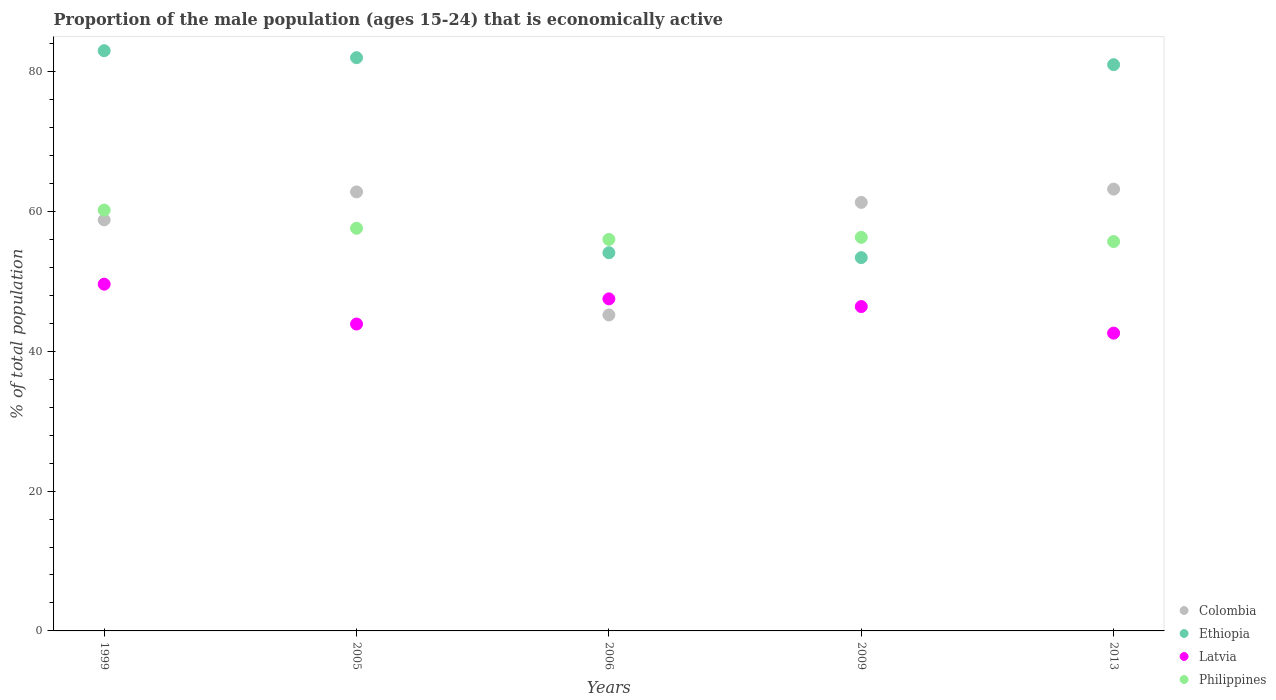Is the number of dotlines equal to the number of legend labels?
Ensure brevity in your answer.  Yes. What is the proportion of the male population that is economically active in Latvia in 2009?
Ensure brevity in your answer.  46.4. Across all years, what is the maximum proportion of the male population that is economically active in Colombia?
Your answer should be compact. 63.2. Across all years, what is the minimum proportion of the male population that is economically active in Philippines?
Your answer should be very brief. 55.7. In which year was the proportion of the male population that is economically active in Philippines minimum?
Make the answer very short. 2013. What is the total proportion of the male population that is economically active in Colombia in the graph?
Offer a very short reply. 291.3. What is the difference between the proportion of the male population that is economically active in Ethiopia in 2009 and that in 2013?
Your answer should be compact. -27.6. What is the difference between the proportion of the male population that is economically active in Philippines in 2005 and the proportion of the male population that is economically active in Ethiopia in 2009?
Give a very brief answer. 4.2. What is the average proportion of the male population that is economically active in Colombia per year?
Make the answer very short. 58.26. In the year 2006, what is the difference between the proportion of the male population that is economically active in Philippines and proportion of the male population that is economically active in Latvia?
Give a very brief answer. 8.5. In how many years, is the proportion of the male population that is economically active in Philippines greater than 36 %?
Keep it short and to the point. 5. What is the ratio of the proportion of the male population that is economically active in Ethiopia in 1999 to that in 2009?
Provide a succinct answer. 1.55. Is the difference between the proportion of the male population that is economically active in Philippines in 1999 and 2009 greater than the difference between the proportion of the male population that is economically active in Latvia in 1999 and 2009?
Your answer should be very brief. Yes. What is the difference between the highest and the second highest proportion of the male population that is economically active in Colombia?
Provide a succinct answer. 0.4. What is the difference between the highest and the lowest proportion of the male population that is economically active in Latvia?
Provide a succinct answer. 7. Is it the case that in every year, the sum of the proportion of the male population that is economically active in Latvia and proportion of the male population that is economically active in Ethiopia  is greater than the sum of proportion of the male population that is economically active in Philippines and proportion of the male population that is economically active in Colombia?
Keep it short and to the point. Yes. Does the proportion of the male population that is economically active in Latvia monotonically increase over the years?
Make the answer very short. No. Is the proportion of the male population that is economically active in Ethiopia strictly less than the proportion of the male population that is economically active in Colombia over the years?
Provide a short and direct response. No. What is the difference between two consecutive major ticks on the Y-axis?
Give a very brief answer. 20. Are the values on the major ticks of Y-axis written in scientific E-notation?
Your answer should be very brief. No. Does the graph contain any zero values?
Keep it short and to the point. No. Does the graph contain grids?
Give a very brief answer. No. Where does the legend appear in the graph?
Make the answer very short. Bottom right. How many legend labels are there?
Ensure brevity in your answer.  4. What is the title of the graph?
Provide a short and direct response. Proportion of the male population (ages 15-24) that is economically active. Does "Northern Mariana Islands" appear as one of the legend labels in the graph?
Offer a terse response. No. What is the label or title of the Y-axis?
Provide a succinct answer. % of total population. What is the % of total population of Colombia in 1999?
Offer a very short reply. 58.8. What is the % of total population in Latvia in 1999?
Ensure brevity in your answer.  49.6. What is the % of total population in Philippines in 1999?
Make the answer very short. 60.2. What is the % of total population in Colombia in 2005?
Give a very brief answer. 62.8. What is the % of total population of Ethiopia in 2005?
Ensure brevity in your answer.  82. What is the % of total population in Latvia in 2005?
Give a very brief answer. 43.9. What is the % of total population in Philippines in 2005?
Ensure brevity in your answer.  57.6. What is the % of total population in Colombia in 2006?
Your answer should be compact. 45.2. What is the % of total population of Ethiopia in 2006?
Keep it short and to the point. 54.1. What is the % of total population of Latvia in 2006?
Make the answer very short. 47.5. What is the % of total population of Philippines in 2006?
Offer a terse response. 56. What is the % of total population in Colombia in 2009?
Keep it short and to the point. 61.3. What is the % of total population in Ethiopia in 2009?
Keep it short and to the point. 53.4. What is the % of total population of Latvia in 2009?
Offer a terse response. 46.4. What is the % of total population in Philippines in 2009?
Offer a terse response. 56.3. What is the % of total population of Colombia in 2013?
Your response must be concise. 63.2. What is the % of total population of Latvia in 2013?
Provide a short and direct response. 42.6. What is the % of total population of Philippines in 2013?
Offer a very short reply. 55.7. Across all years, what is the maximum % of total population of Colombia?
Give a very brief answer. 63.2. Across all years, what is the maximum % of total population in Ethiopia?
Offer a very short reply. 83. Across all years, what is the maximum % of total population of Latvia?
Keep it short and to the point. 49.6. Across all years, what is the maximum % of total population of Philippines?
Offer a very short reply. 60.2. Across all years, what is the minimum % of total population in Colombia?
Give a very brief answer. 45.2. Across all years, what is the minimum % of total population of Ethiopia?
Offer a very short reply. 53.4. Across all years, what is the minimum % of total population of Latvia?
Your answer should be compact. 42.6. Across all years, what is the minimum % of total population in Philippines?
Offer a very short reply. 55.7. What is the total % of total population in Colombia in the graph?
Your answer should be compact. 291.3. What is the total % of total population in Ethiopia in the graph?
Your response must be concise. 353.5. What is the total % of total population in Latvia in the graph?
Provide a succinct answer. 230. What is the total % of total population of Philippines in the graph?
Your response must be concise. 285.8. What is the difference between the % of total population of Philippines in 1999 and that in 2005?
Offer a very short reply. 2.6. What is the difference between the % of total population of Ethiopia in 1999 and that in 2006?
Offer a terse response. 28.9. What is the difference between the % of total population of Latvia in 1999 and that in 2006?
Your answer should be very brief. 2.1. What is the difference between the % of total population of Philippines in 1999 and that in 2006?
Offer a terse response. 4.2. What is the difference between the % of total population of Colombia in 1999 and that in 2009?
Offer a terse response. -2.5. What is the difference between the % of total population of Ethiopia in 1999 and that in 2009?
Offer a terse response. 29.6. What is the difference between the % of total population of Latvia in 1999 and that in 2009?
Provide a succinct answer. 3.2. What is the difference between the % of total population in Colombia in 1999 and that in 2013?
Make the answer very short. -4.4. What is the difference between the % of total population in Colombia in 2005 and that in 2006?
Give a very brief answer. 17.6. What is the difference between the % of total population of Ethiopia in 2005 and that in 2006?
Your response must be concise. 27.9. What is the difference between the % of total population in Latvia in 2005 and that in 2006?
Your answer should be very brief. -3.6. What is the difference between the % of total population of Colombia in 2005 and that in 2009?
Your answer should be compact. 1.5. What is the difference between the % of total population of Ethiopia in 2005 and that in 2009?
Provide a succinct answer. 28.6. What is the difference between the % of total population in Latvia in 2005 and that in 2009?
Give a very brief answer. -2.5. What is the difference between the % of total population of Philippines in 2005 and that in 2009?
Your answer should be very brief. 1.3. What is the difference between the % of total population of Colombia in 2005 and that in 2013?
Offer a terse response. -0.4. What is the difference between the % of total population in Ethiopia in 2005 and that in 2013?
Give a very brief answer. 1. What is the difference between the % of total population of Philippines in 2005 and that in 2013?
Offer a terse response. 1.9. What is the difference between the % of total population of Colombia in 2006 and that in 2009?
Make the answer very short. -16.1. What is the difference between the % of total population of Ethiopia in 2006 and that in 2009?
Your response must be concise. 0.7. What is the difference between the % of total population in Colombia in 2006 and that in 2013?
Keep it short and to the point. -18. What is the difference between the % of total population of Ethiopia in 2006 and that in 2013?
Offer a very short reply. -26.9. What is the difference between the % of total population in Philippines in 2006 and that in 2013?
Ensure brevity in your answer.  0.3. What is the difference between the % of total population of Colombia in 2009 and that in 2013?
Offer a terse response. -1.9. What is the difference between the % of total population in Ethiopia in 2009 and that in 2013?
Give a very brief answer. -27.6. What is the difference between the % of total population of Philippines in 2009 and that in 2013?
Your response must be concise. 0.6. What is the difference between the % of total population in Colombia in 1999 and the % of total population in Ethiopia in 2005?
Ensure brevity in your answer.  -23.2. What is the difference between the % of total population of Colombia in 1999 and the % of total population of Philippines in 2005?
Keep it short and to the point. 1.2. What is the difference between the % of total population in Ethiopia in 1999 and the % of total population in Latvia in 2005?
Provide a succinct answer. 39.1. What is the difference between the % of total population of Ethiopia in 1999 and the % of total population of Philippines in 2005?
Make the answer very short. 25.4. What is the difference between the % of total population in Ethiopia in 1999 and the % of total population in Latvia in 2006?
Your answer should be very brief. 35.5. What is the difference between the % of total population of Colombia in 1999 and the % of total population of Latvia in 2009?
Give a very brief answer. 12.4. What is the difference between the % of total population of Ethiopia in 1999 and the % of total population of Latvia in 2009?
Make the answer very short. 36.6. What is the difference between the % of total population of Ethiopia in 1999 and the % of total population of Philippines in 2009?
Offer a terse response. 26.7. What is the difference between the % of total population in Latvia in 1999 and the % of total population in Philippines in 2009?
Provide a short and direct response. -6.7. What is the difference between the % of total population in Colombia in 1999 and the % of total population in Ethiopia in 2013?
Your answer should be very brief. -22.2. What is the difference between the % of total population in Colombia in 1999 and the % of total population in Philippines in 2013?
Your answer should be compact. 3.1. What is the difference between the % of total population of Ethiopia in 1999 and the % of total population of Latvia in 2013?
Ensure brevity in your answer.  40.4. What is the difference between the % of total population in Ethiopia in 1999 and the % of total population in Philippines in 2013?
Offer a terse response. 27.3. What is the difference between the % of total population of Colombia in 2005 and the % of total population of Ethiopia in 2006?
Give a very brief answer. 8.7. What is the difference between the % of total population in Colombia in 2005 and the % of total population in Latvia in 2006?
Provide a succinct answer. 15.3. What is the difference between the % of total population in Colombia in 2005 and the % of total population in Philippines in 2006?
Provide a succinct answer. 6.8. What is the difference between the % of total population of Ethiopia in 2005 and the % of total population of Latvia in 2006?
Your response must be concise. 34.5. What is the difference between the % of total population in Latvia in 2005 and the % of total population in Philippines in 2006?
Your response must be concise. -12.1. What is the difference between the % of total population of Colombia in 2005 and the % of total population of Latvia in 2009?
Ensure brevity in your answer.  16.4. What is the difference between the % of total population of Ethiopia in 2005 and the % of total population of Latvia in 2009?
Provide a short and direct response. 35.6. What is the difference between the % of total population in Ethiopia in 2005 and the % of total population in Philippines in 2009?
Make the answer very short. 25.7. What is the difference between the % of total population in Latvia in 2005 and the % of total population in Philippines in 2009?
Make the answer very short. -12.4. What is the difference between the % of total population in Colombia in 2005 and the % of total population in Ethiopia in 2013?
Offer a terse response. -18.2. What is the difference between the % of total population in Colombia in 2005 and the % of total population in Latvia in 2013?
Ensure brevity in your answer.  20.2. What is the difference between the % of total population of Colombia in 2005 and the % of total population of Philippines in 2013?
Offer a terse response. 7.1. What is the difference between the % of total population of Ethiopia in 2005 and the % of total population of Latvia in 2013?
Your response must be concise. 39.4. What is the difference between the % of total population in Ethiopia in 2005 and the % of total population in Philippines in 2013?
Ensure brevity in your answer.  26.3. What is the difference between the % of total population in Colombia in 2006 and the % of total population in Ethiopia in 2009?
Provide a short and direct response. -8.2. What is the difference between the % of total population of Colombia in 2006 and the % of total population of Ethiopia in 2013?
Your answer should be compact. -35.8. What is the difference between the % of total population of Ethiopia in 2006 and the % of total population of Latvia in 2013?
Give a very brief answer. 11.5. What is the difference between the % of total population of Colombia in 2009 and the % of total population of Ethiopia in 2013?
Your response must be concise. -19.7. What is the difference between the % of total population in Ethiopia in 2009 and the % of total population in Latvia in 2013?
Provide a short and direct response. 10.8. What is the difference between the % of total population of Latvia in 2009 and the % of total population of Philippines in 2013?
Offer a very short reply. -9.3. What is the average % of total population in Colombia per year?
Your answer should be compact. 58.26. What is the average % of total population of Ethiopia per year?
Provide a short and direct response. 70.7. What is the average % of total population of Philippines per year?
Ensure brevity in your answer.  57.16. In the year 1999, what is the difference between the % of total population of Colombia and % of total population of Ethiopia?
Provide a succinct answer. -24.2. In the year 1999, what is the difference between the % of total population in Colombia and % of total population in Philippines?
Offer a very short reply. -1.4. In the year 1999, what is the difference between the % of total population of Ethiopia and % of total population of Latvia?
Provide a succinct answer. 33.4. In the year 1999, what is the difference between the % of total population of Ethiopia and % of total population of Philippines?
Ensure brevity in your answer.  22.8. In the year 2005, what is the difference between the % of total population in Colombia and % of total population in Ethiopia?
Your response must be concise. -19.2. In the year 2005, what is the difference between the % of total population in Ethiopia and % of total population in Latvia?
Ensure brevity in your answer.  38.1. In the year 2005, what is the difference between the % of total population of Ethiopia and % of total population of Philippines?
Your response must be concise. 24.4. In the year 2005, what is the difference between the % of total population of Latvia and % of total population of Philippines?
Your answer should be compact. -13.7. In the year 2006, what is the difference between the % of total population in Colombia and % of total population in Ethiopia?
Your answer should be compact. -8.9. In the year 2006, what is the difference between the % of total population of Colombia and % of total population of Latvia?
Make the answer very short. -2.3. In the year 2006, what is the difference between the % of total population in Ethiopia and % of total population in Philippines?
Give a very brief answer. -1.9. In the year 2006, what is the difference between the % of total population of Latvia and % of total population of Philippines?
Provide a succinct answer. -8.5. In the year 2009, what is the difference between the % of total population in Colombia and % of total population in Ethiopia?
Make the answer very short. 7.9. In the year 2009, what is the difference between the % of total population in Colombia and % of total population in Latvia?
Your answer should be very brief. 14.9. In the year 2009, what is the difference between the % of total population of Ethiopia and % of total population of Latvia?
Offer a very short reply. 7. In the year 2009, what is the difference between the % of total population in Ethiopia and % of total population in Philippines?
Keep it short and to the point. -2.9. In the year 2009, what is the difference between the % of total population of Latvia and % of total population of Philippines?
Make the answer very short. -9.9. In the year 2013, what is the difference between the % of total population in Colombia and % of total population in Ethiopia?
Your answer should be very brief. -17.8. In the year 2013, what is the difference between the % of total population in Colombia and % of total population in Latvia?
Offer a very short reply. 20.6. In the year 2013, what is the difference between the % of total population in Ethiopia and % of total population in Latvia?
Your answer should be very brief. 38.4. In the year 2013, what is the difference between the % of total population in Ethiopia and % of total population in Philippines?
Ensure brevity in your answer.  25.3. What is the ratio of the % of total population in Colombia in 1999 to that in 2005?
Keep it short and to the point. 0.94. What is the ratio of the % of total population in Ethiopia in 1999 to that in 2005?
Provide a short and direct response. 1.01. What is the ratio of the % of total population of Latvia in 1999 to that in 2005?
Your answer should be very brief. 1.13. What is the ratio of the % of total population of Philippines in 1999 to that in 2005?
Your answer should be compact. 1.05. What is the ratio of the % of total population of Colombia in 1999 to that in 2006?
Your answer should be very brief. 1.3. What is the ratio of the % of total population of Ethiopia in 1999 to that in 2006?
Your answer should be very brief. 1.53. What is the ratio of the % of total population in Latvia in 1999 to that in 2006?
Your answer should be compact. 1.04. What is the ratio of the % of total population of Philippines in 1999 to that in 2006?
Your response must be concise. 1.07. What is the ratio of the % of total population of Colombia in 1999 to that in 2009?
Keep it short and to the point. 0.96. What is the ratio of the % of total population in Ethiopia in 1999 to that in 2009?
Ensure brevity in your answer.  1.55. What is the ratio of the % of total population in Latvia in 1999 to that in 2009?
Your response must be concise. 1.07. What is the ratio of the % of total population in Philippines in 1999 to that in 2009?
Your answer should be very brief. 1.07. What is the ratio of the % of total population in Colombia in 1999 to that in 2013?
Provide a short and direct response. 0.93. What is the ratio of the % of total population in Ethiopia in 1999 to that in 2013?
Offer a very short reply. 1.02. What is the ratio of the % of total population of Latvia in 1999 to that in 2013?
Provide a succinct answer. 1.16. What is the ratio of the % of total population of Philippines in 1999 to that in 2013?
Keep it short and to the point. 1.08. What is the ratio of the % of total population in Colombia in 2005 to that in 2006?
Keep it short and to the point. 1.39. What is the ratio of the % of total population of Ethiopia in 2005 to that in 2006?
Give a very brief answer. 1.52. What is the ratio of the % of total population of Latvia in 2005 to that in 2006?
Your answer should be very brief. 0.92. What is the ratio of the % of total population of Philippines in 2005 to that in 2006?
Provide a succinct answer. 1.03. What is the ratio of the % of total population in Colombia in 2005 to that in 2009?
Provide a succinct answer. 1.02. What is the ratio of the % of total population in Ethiopia in 2005 to that in 2009?
Keep it short and to the point. 1.54. What is the ratio of the % of total population of Latvia in 2005 to that in 2009?
Keep it short and to the point. 0.95. What is the ratio of the % of total population of Philippines in 2005 to that in 2009?
Make the answer very short. 1.02. What is the ratio of the % of total population of Colombia in 2005 to that in 2013?
Give a very brief answer. 0.99. What is the ratio of the % of total population of Ethiopia in 2005 to that in 2013?
Offer a very short reply. 1.01. What is the ratio of the % of total population in Latvia in 2005 to that in 2013?
Your response must be concise. 1.03. What is the ratio of the % of total population of Philippines in 2005 to that in 2013?
Your answer should be compact. 1.03. What is the ratio of the % of total population in Colombia in 2006 to that in 2009?
Your answer should be compact. 0.74. What is the ratio of the % of total population in Ethiopia in 2006 to that in 2009?
Give a very brief answer. 1.01. What is the ratio of the % of total population of Latvia in 2006 to that in 2009?
Your response must be concise. 1.02. What is the ratio of the % of total population of Philippines in 2006 to that in 2009?
Make the answer very short. 0.99. What is the ratio of the % of total population in Colombia in 2006 to that in 2013?
Ensure brevity in your answer.  0.72. What is the ratio of the % of total population of Ethiopia in 2006 to that in 2013?
Your answer should be very brief. 0.67. What is the ratio of the % of total population of Latvia in 2006 to that in 2013?
Ensure brevity in your answer.  1.11. What is the ratio of the % of total population in Philippines in 2006 to that in 2013?
Offer a terse response. 1.01. What is the ratio of the % of total population in Colombia in 2009 to that in 2013?
Give a very brief answer. 0.97. What is the ratio of the % of total population of Ethiopia in 2009 to that in 2013?
Make the answer very short. 0.66. What is the ratio of the % of total population of Latvia in 2009 to that in 2013?
Your answer should be compact. 1.09. What is the ratio of the % of total population of Philippines in 2009 to that in 2013?
Make the answer very short. 1.01. What is the difference between the highest and the second highest % of total population of Colombia?
Ensure brevity in your answer.  0.4. What is the difference between the highest and the second highest % of total population of Philippines?
Provide a short and direct response. 2.6. What is the difference between the highest and the lowest % of total population in Ethiopia?
Your response must be concise. 29.6. What is the difference between the highest and the lowest % of total population in Philippines?
Keep it short and to the point. 4.5. 